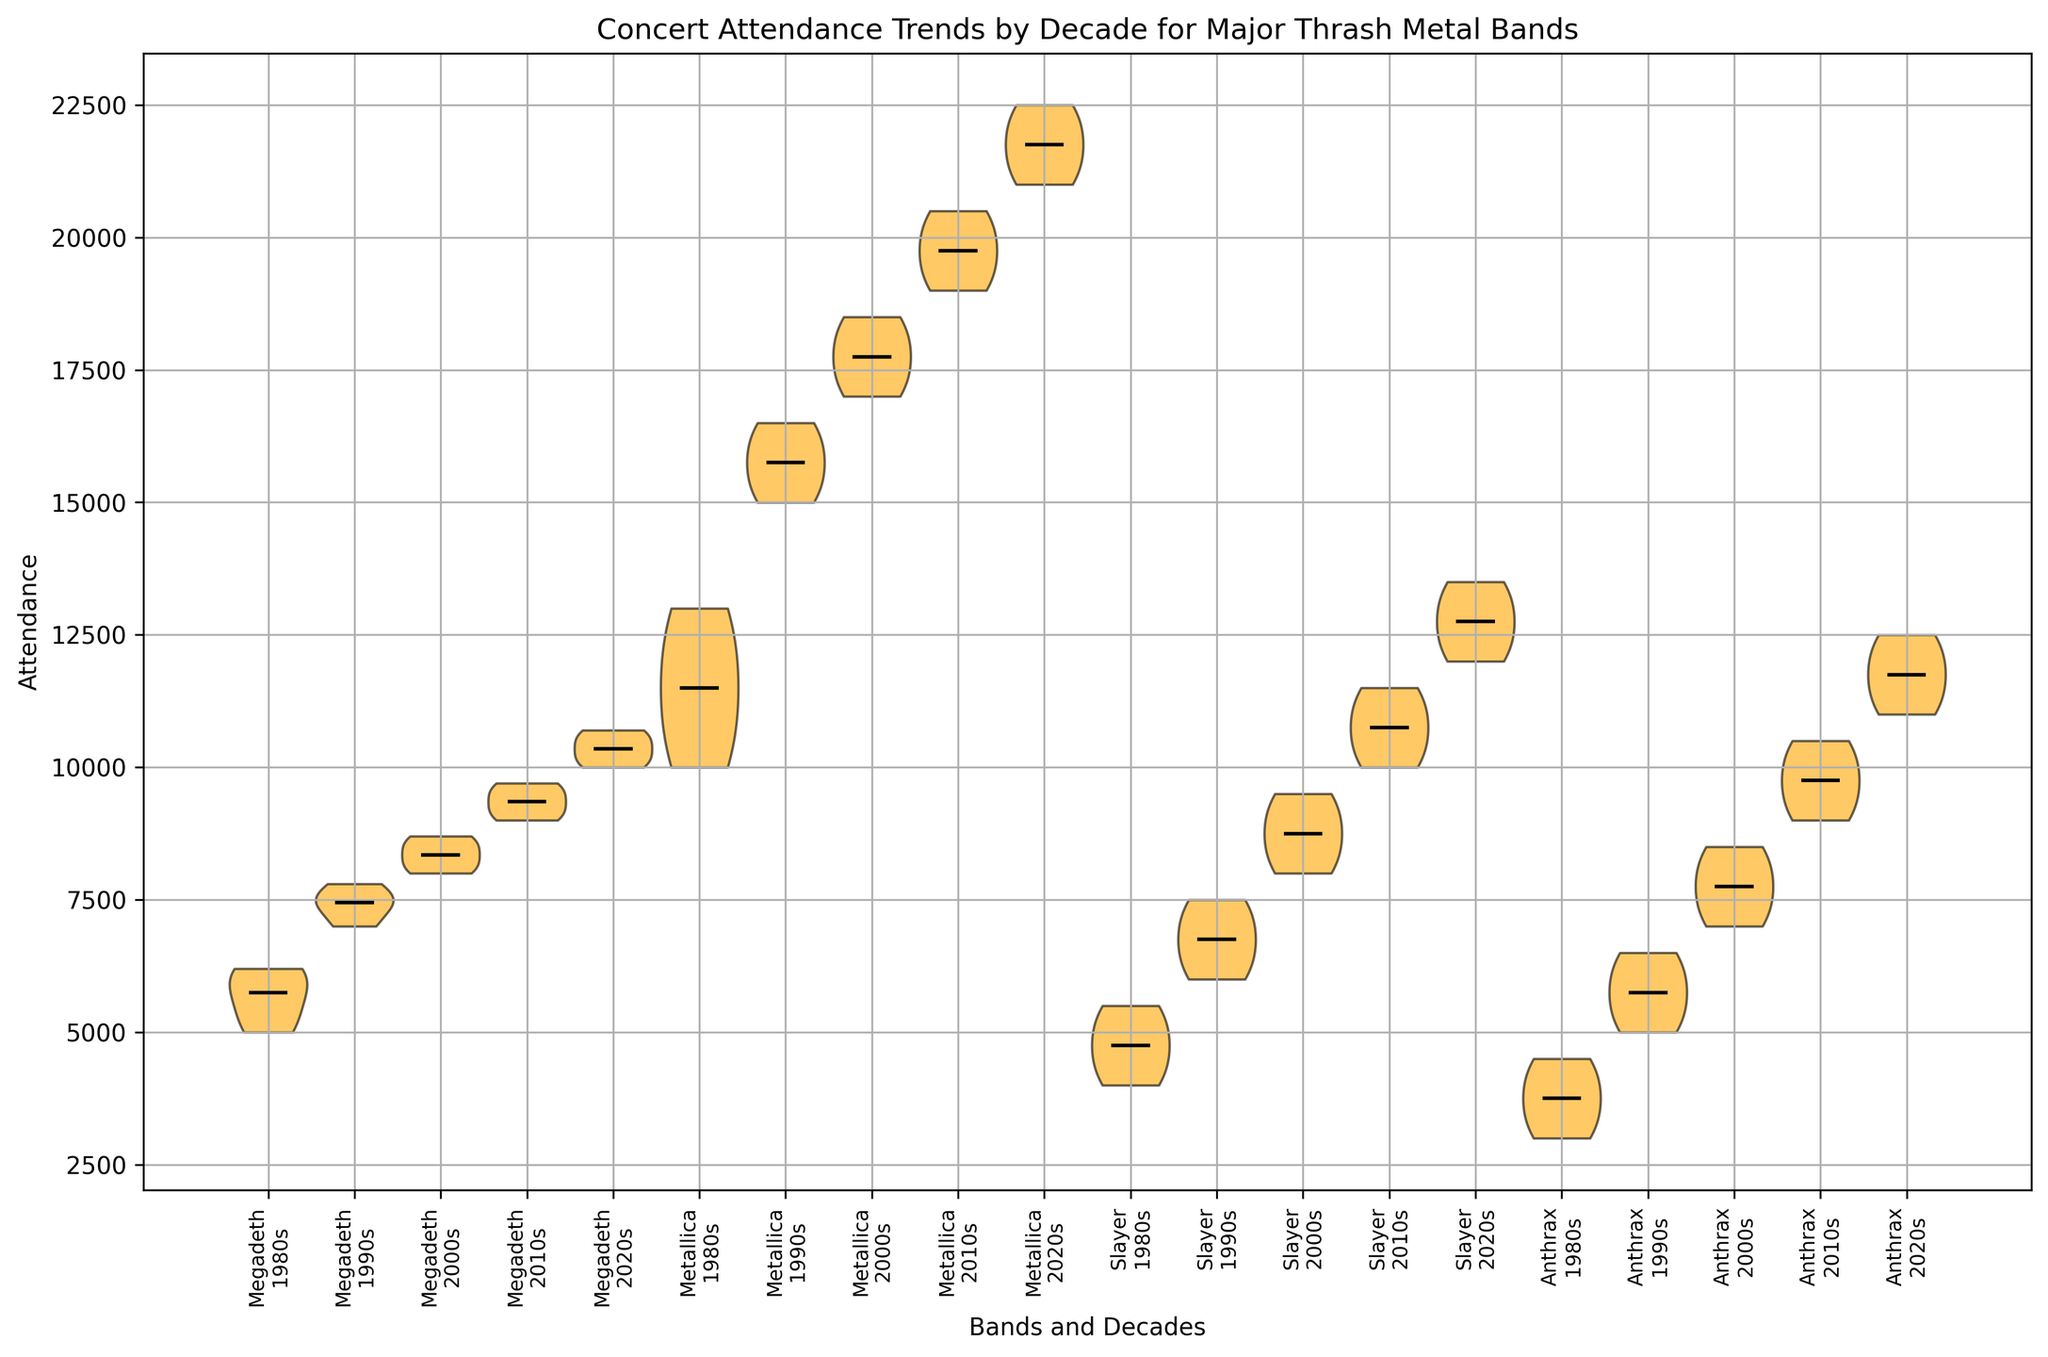Which band has the highest median concert attendance during the 2020s? To determine this, look at the violin plots for Metallica, Megadeth, Slayer, and Anthrax. Identify the median lines (usually the horizontal line in the center). Metallica's median is the highest among them.
Answer: Metallica What is the average concert attendance for Megadeth in the 2010s? Identify the data points in Megadeth's violin plot for the 2010s. The data points are 9000, 9200, 9500, 9700. Calculate the average: (9000 + 9200 + 9500 + 9700) / 4 = 9350.
Answer: 9350 Which band saw the most significant increase in median attendance from the 1980s to the 1990s? Compare the median lines between the 1980s and 1990s for all bands. Metallica shows the largest increase, going from around 11500 in the 1980s to 15750 in the 1990s.
Answer: Metallica Looking at the violin plot, how does Megadeth's attendance trend compare to Metallica's over decades? Observe the shapes and median lines of the violin plots for both bands from the 1980s to the 2020s. Metallica has higher attendance medians across all decades, with a more pronounced upward trend. Megadeth also increases, but more gradually.
Answer: Metallica has higher attendance and a steeper upward trend What is the range of concert attendance for Slayer in the 2000s? Examine Slayer's violin plot for the 2000s. Identify the minimum and maximum data points (the extent of the violin plot). The data points are 8000 to 9500. The range is 9500 - 8000 = 1500.
Answer: 1500 Between Anthrax and Slayer, which band had higher variability in concert attendance during the 2010s? Compare the spread (width) of the violin plots for Anthrax and Slayer in the 2010s. Anthrax's plot appears to have a wider spread than Slayer's, indicating higher variability.
Answer: Anthrax How does the visual width of the violin plots reflect attendance variability for Megadeth in the 1980s? The width of the violin plot indicates the distribution of attendance values. For Megadeth in the 1980s, the plot is relatively narrow, indicating lower variability in attendance.
Answer: Lower variability Which band had relatively stable attendance trends across the decades? Look for bands with narrow and consistent violin plots across all decades. Slayer has relatively stable and less variable attendance trends compared to the spikes seen in bands like Metallica.
Answer: Slayer 